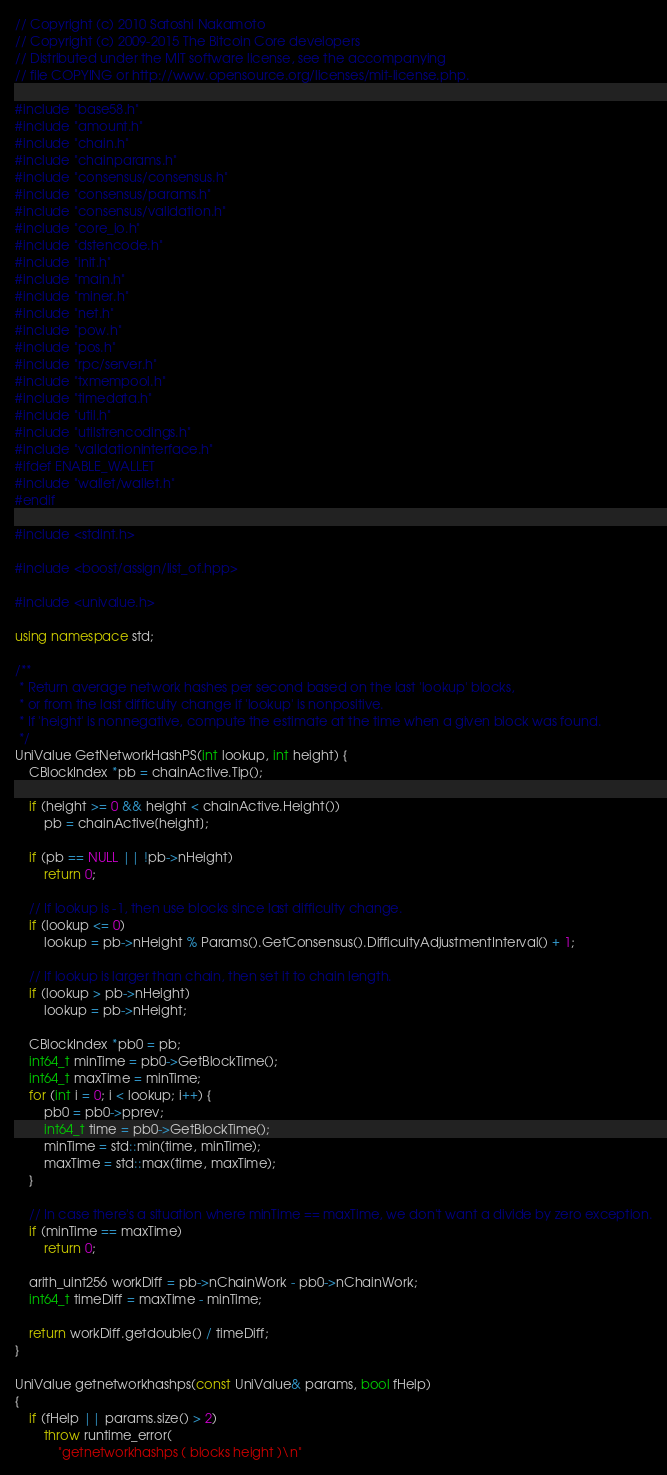<code> <loc_0><loc_0><loc_500><loc_500><_C++_>// Copyright (c) 2010 Satoshi Nakamoto
// Copyright (c) 2009-2015 The Bitcoin Core developers
// Distributed under the MIT software license, see the accompanying
// file COPYING or http://www.opensource.org/licenses/mit-license.php.

#include "base58.h"
#include "amount.h"
#include "chain.h"
#include "chainparams.h"
#include "consensus/consensus.h"
#include "consensus/params.h"
#include "consensus/validation.h"
#include "core_io.h"
#include "dstencode.h"
#include "init.h"
#include "main.h"
#include "miner.h"
#include "net.h"
#include "pow.h"
#include "pos.h"
#include "rpc/server.h"
#include "txmempool.h"
#include "timedata.h"
#include "util.h"
#include "utilstrencodings.h"
#include "validationinterface.h"
#ifdef ENABLE_WALLET
#include "wallet/wallet.h"
#endif

#include <stdint.h>

#include <boost/assign/list_of.hpp>

#include <univalue.h>

using namespace std;

/**
 * Return average network hashes per second based on the last 'lookup' blocks,
 * or from the last difficulty change if 'lookup' is nonpositive.
 * If 'height' is nonnegative, compute the estimate at the time when a given block was found.
 */
UniValue GetNetworkHashPS(int lookup, int height) {
    CBlockIndex *pb = chainActive.Tip();

    if (height >= 0 && height < chainActive.Height())
        pb = chainActive[height];

    if (pb == NULL || !pb->nHeight)
        return 0;

    // If lookup is -1, then use blocks since last difficulty change.
    if (lookup <= 0)
        lookup = pb->nHeight % Params().GetConsensus().DifficultyAdjustmentInterval() + 1;

    // If lookup is larger than chain, then set it to chain length.
    if (lookup > pb->nHeight)
        lookup = pb->nHeight;

    CBlockIndex *pb0 = pb;
    int64_t minTime = pb0->GetBlockTime();
    int64_t maxTime = minTime;
    for (int i = 0; i < lookup; i++) {
        pb0 = pb0->pprev;
        int64_t time = pb0->GetBlockTime();
        minTime = std::min(time, minTime);
        maxTime = std::max(time, maxTime);
    }

    // In case there's a situation where minTime == maxTime, we don't want a divide by zero exception.
    if (minTime == maxTime)
        return 0;

    arith_uint256 workDiff = pb->nChainWork - pb0->nChainWork;
    int64_t timeDiff = maxTime - minTime;

    return workDiff.getdouble() / timeDiff;
}

UniValue getnetworkhashps(const UniValue& params, bool fHelp)
{
    if (fHelp || params.size() > 2)
        throw runtime_error(
            "getnetworkhashps ( blocks height )\n"</code> 